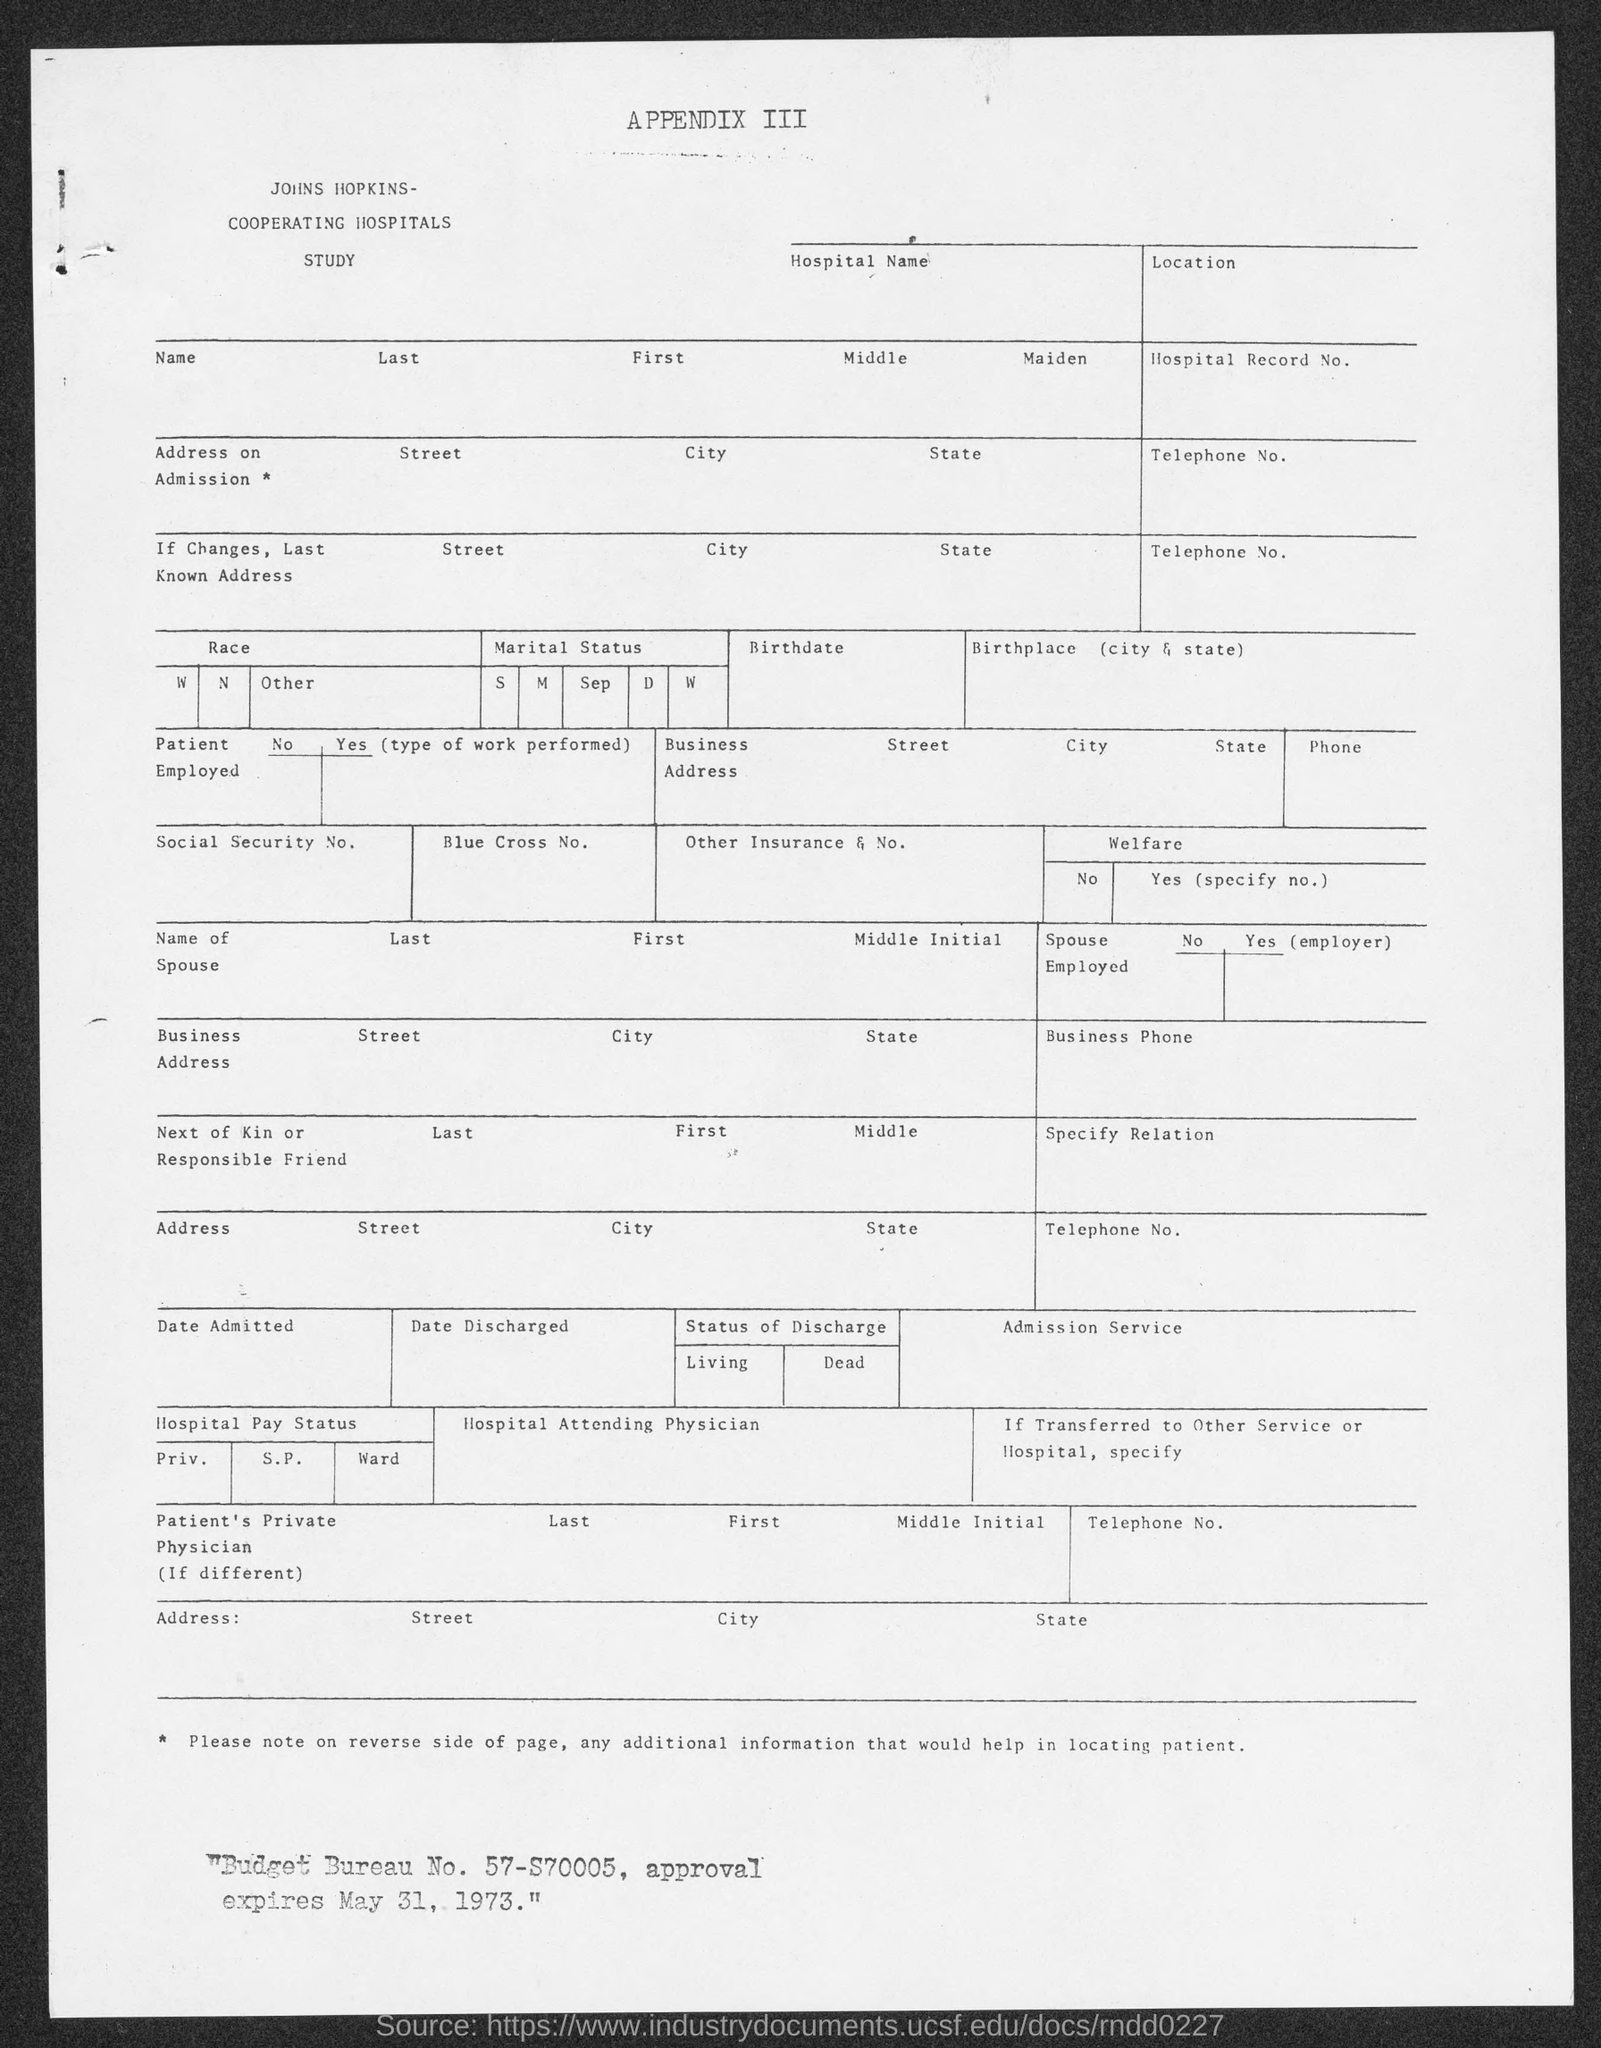What is the budget bureau no.?
Provide a succinct answer. 57-S70005. 